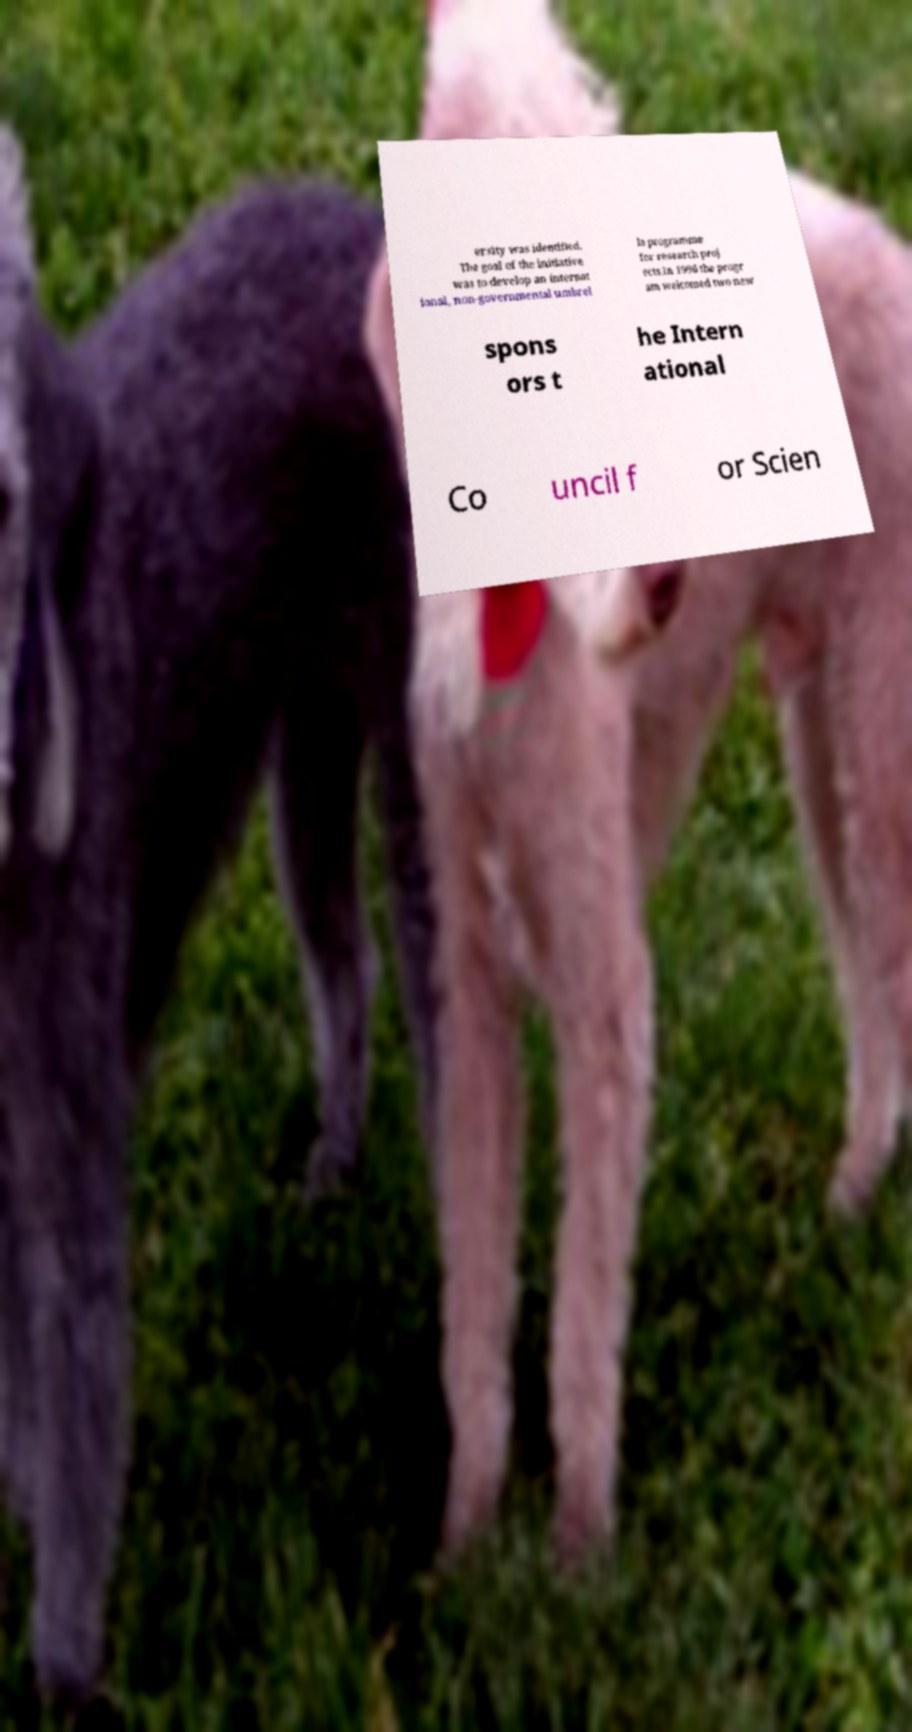There's text embedded in this image that I need extracted. Can you transcribe it verbatim? ersity was identified. The goal of the initiative was to develop an internat ional, non-governmental umbrel la programme for research proj ects.In 1996 the progr am welcomed two new spons ors t he Intern ational Co uncil f or Scien 